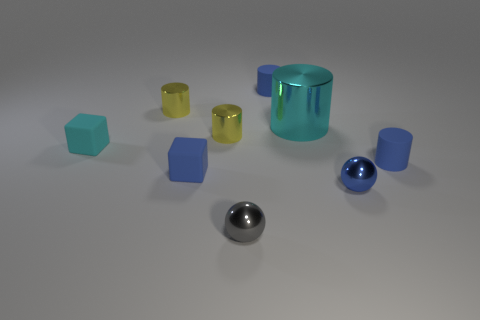How many metal things are either small green cylinders or blue blocks?
Offer a very short reply. 0. What shape is the small thing that is the same color as the large cylinder?
Give a very brief answer. Cube. There is a small blue sphere on the right side of the big metal object; what material is it?
Make the answer very short. Metal. How many objects are either metal things or tiny blue rubber cylinders in front of the cyan block?
Offer a terse response. 6. There is a gray thing that is the same size as the blue metallic thing; what is its shape?
Make the answer very short. Sphere. What number of small matte objects have the same color as the big cylinder?
Your response must be concise. 1. Does the tiny yellow thing that is in front of the large cyan metal cylinder have the same material as the tiny gray thing?
Provide a short and direct response. Yes. There is a gray object; what shape is it?
Keep it short and to the point. Sphere. How many yellow things are either large cylinders or small shiny balls?
Make the answer very short. 0. What number of other things are the same material as the small gray sphere?
Your answer should be compact. 4. 